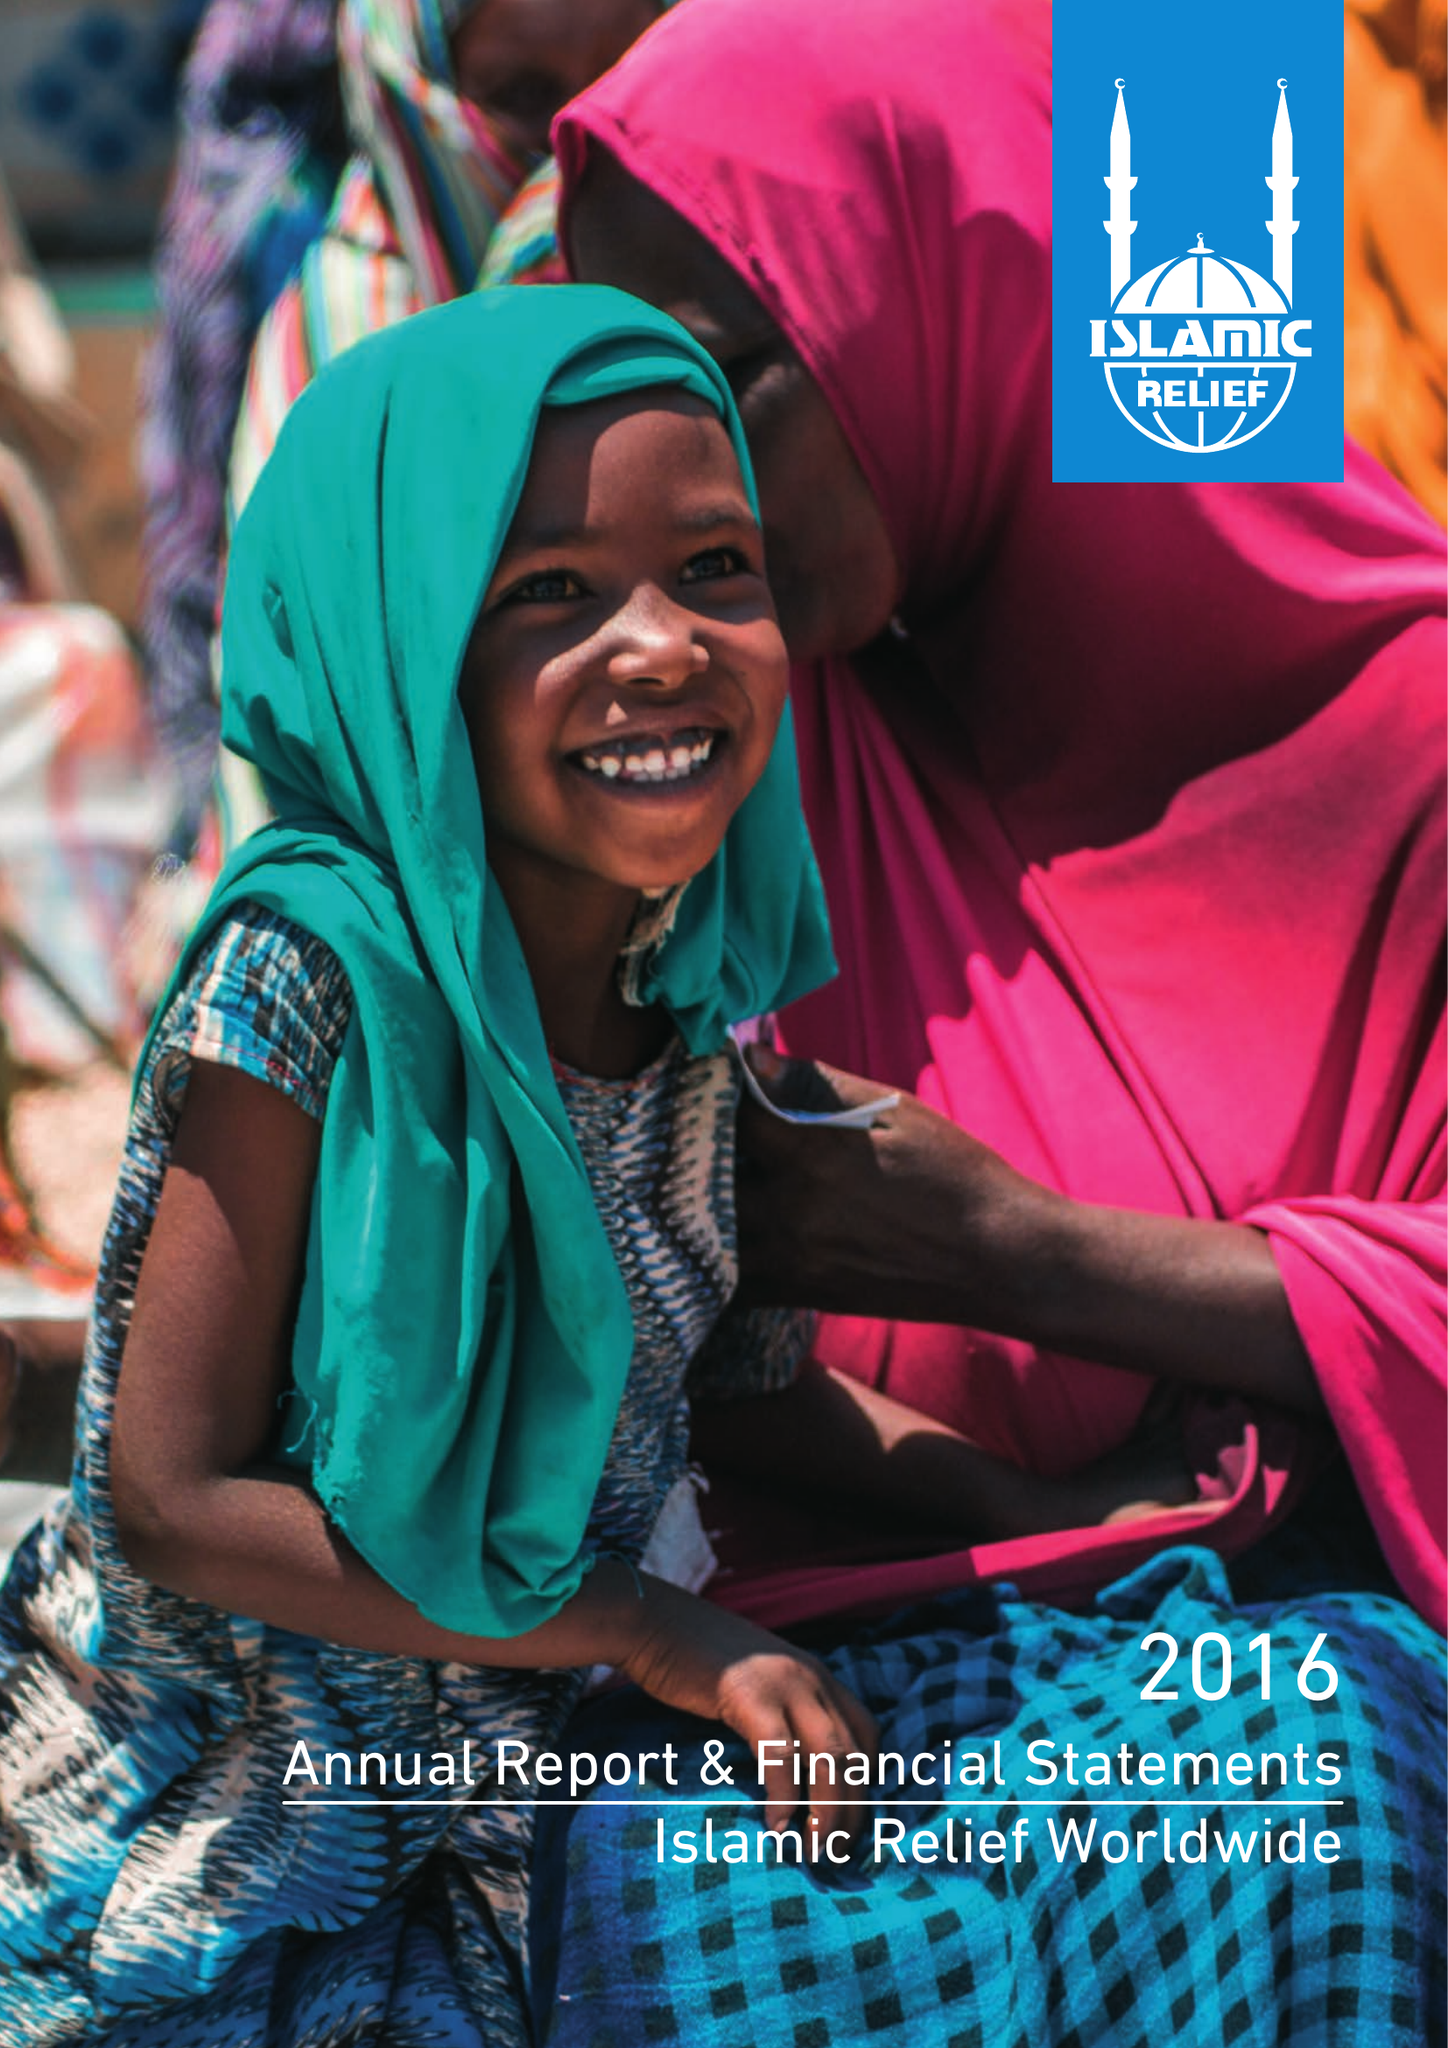What is the value for the charity_number?
Answer the question using a single word or phrase. 328158 